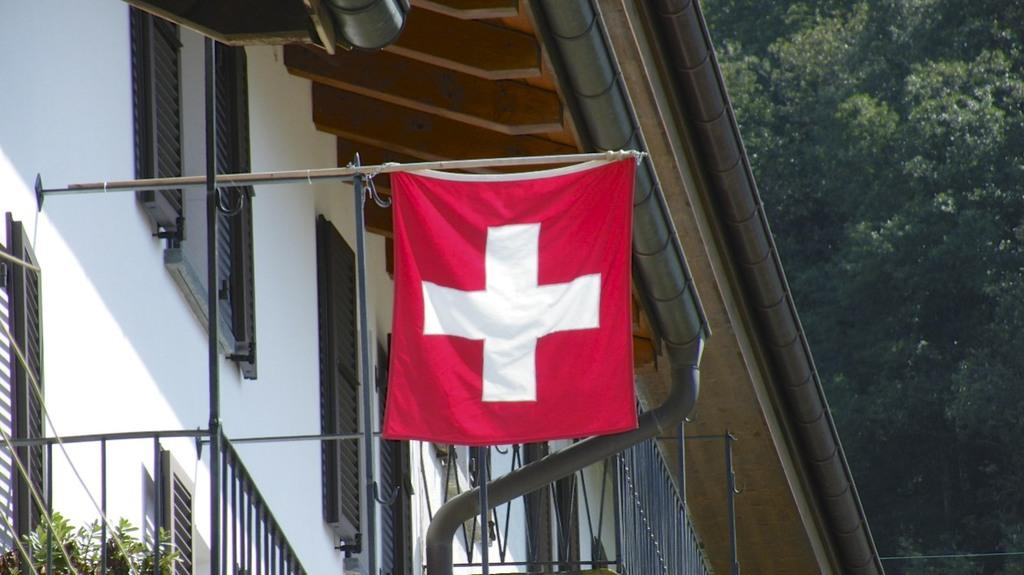What structure is located on the left side of the image? There is a building on the left side of the image. What features can be seen on the left side of the image? Grilles, leaves, a flag, rods, and pipes are present on the left side of the image. What type of vegetation is on the right side of the image? There are trees on the right side of the image. What type of bird can be seen on the wrist of the person in the image? There is no person or wrist visible in the image; it only features a building, leaves, a flag, rods, pipes, and trees. 